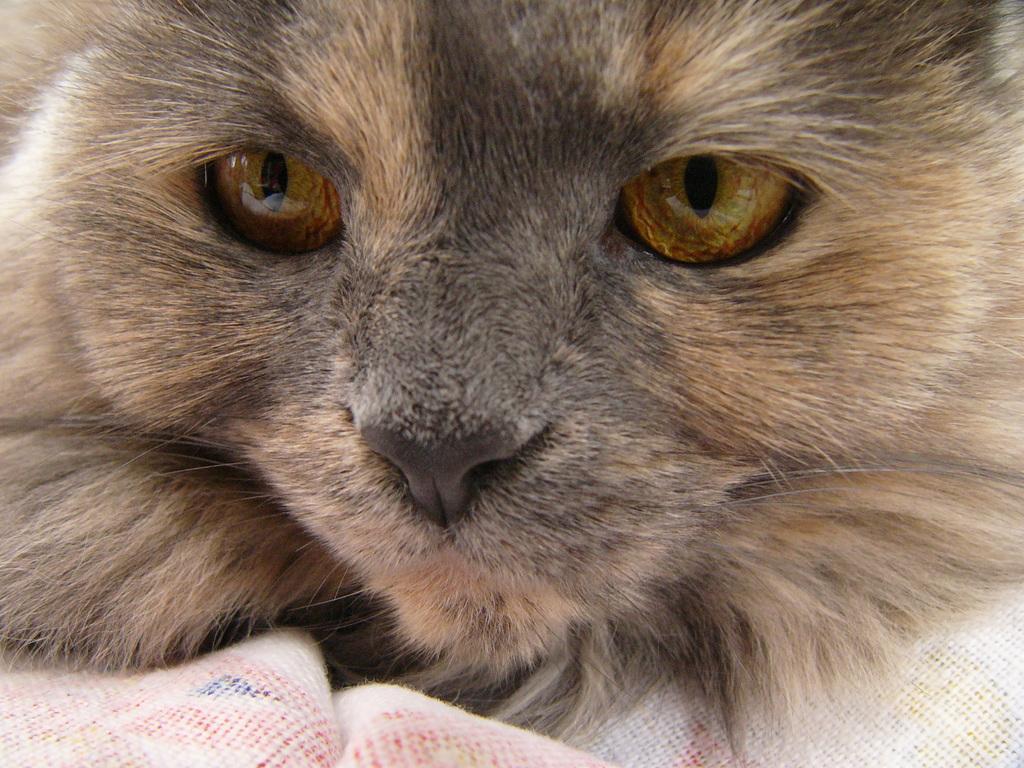Describe this image in one or two sentences. In this image I can see a cat which is brown and black in color on the white colored object. I can see its eyes are gold, orange and black in color and its nose is black in color. 